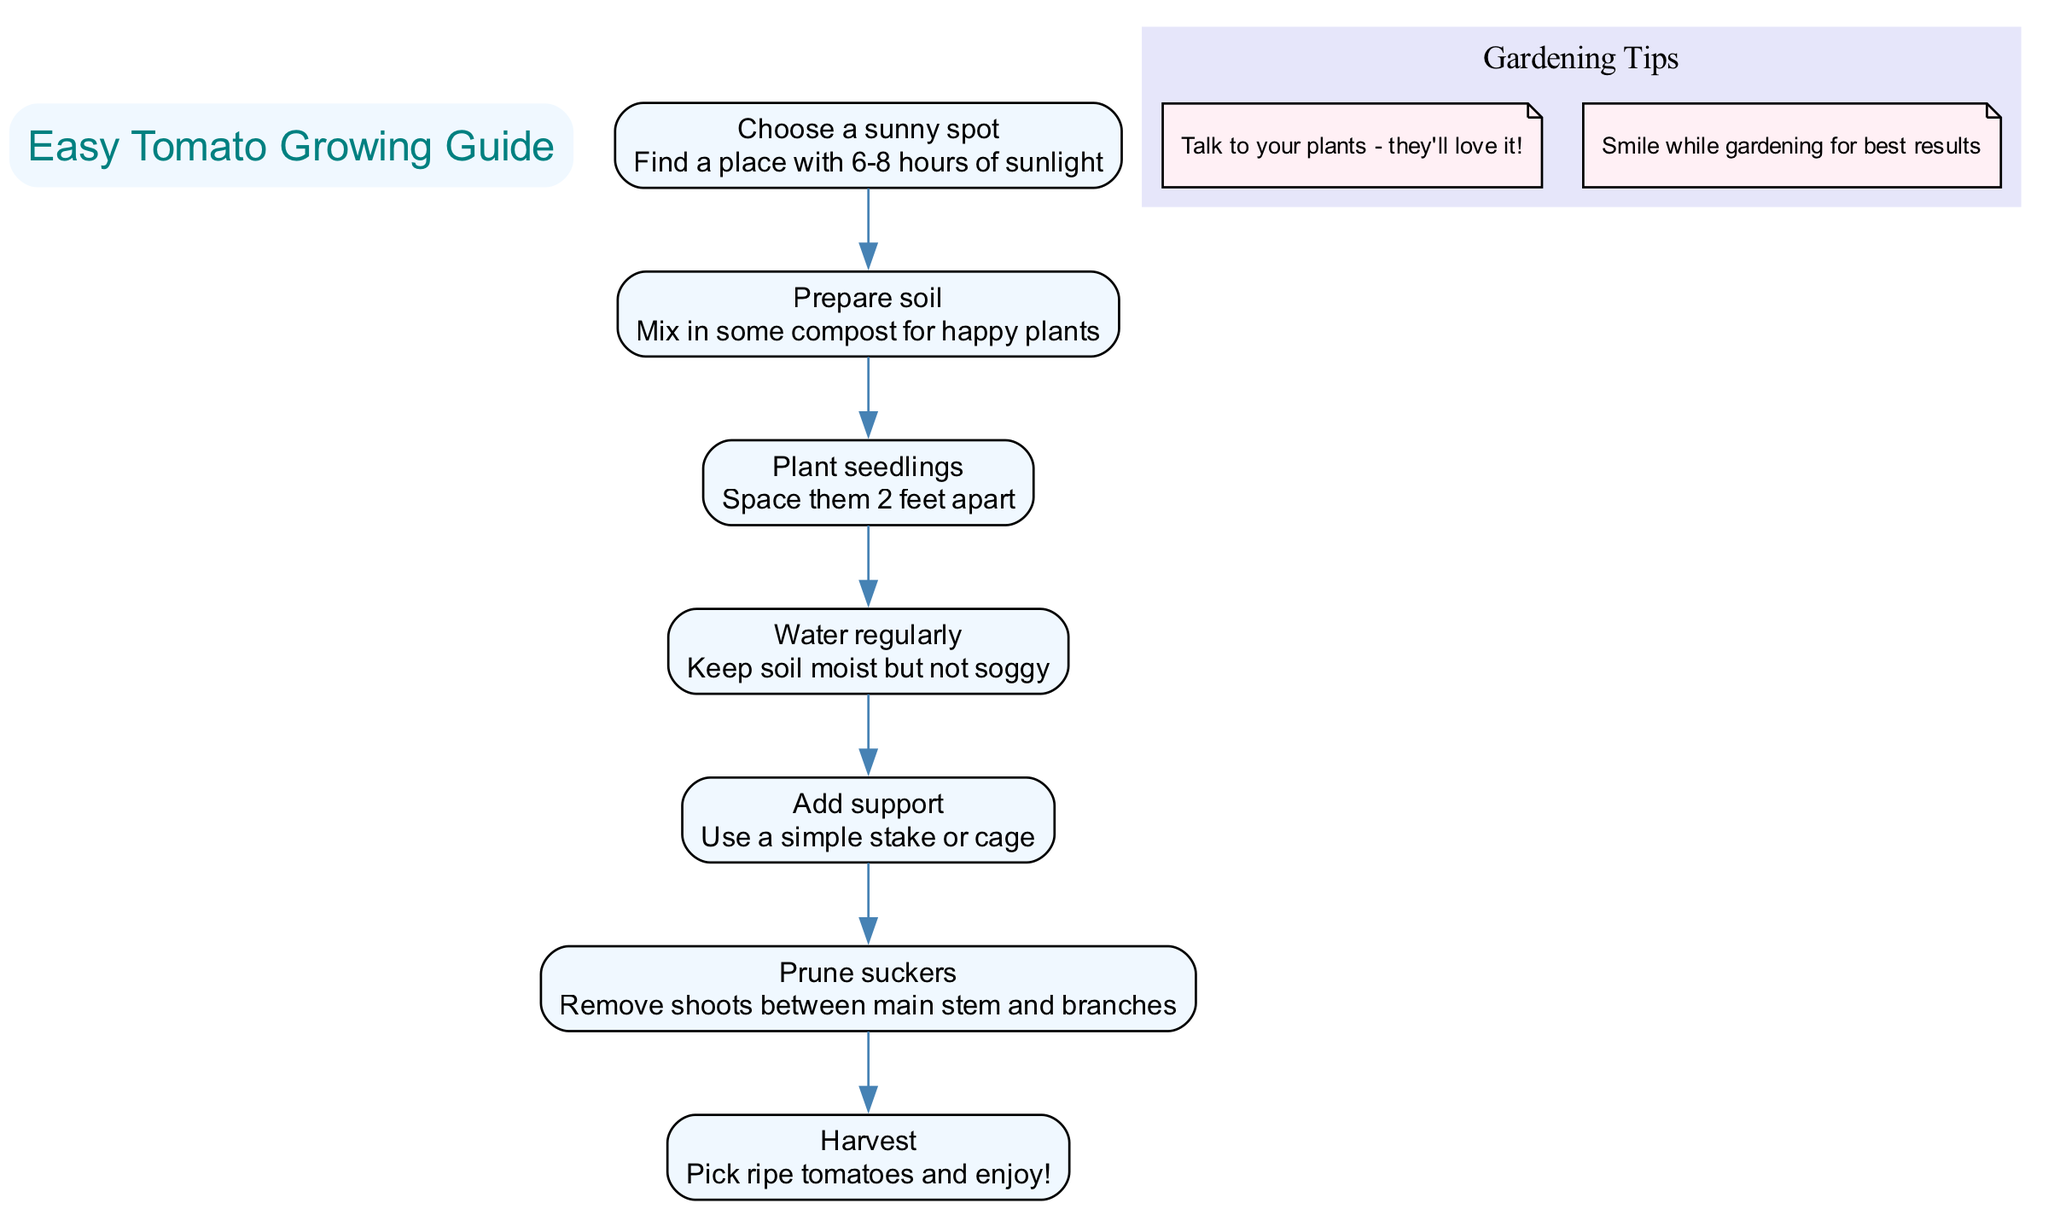What is the first step in planting a tomato? The first step listed in the diagram is to "Choose a sunny spot." This step is the first in the sequence and focuses on finding a location with sufficient sunlight.
Answer: Choose a sunny spot How many steps are in the guide? The diagram contains a total of 7 steps as outlined in the steps section. Each step is identified by a name and description which adds up to 7 sequential actions.
Answer: 7 What should you add for happy plants? The description for the second step mentions to "Mix in some compost for happy plants." This information is directly linked to the step of preparing the soil.
Answer: Compost What is the purpose of adding support? The description for the fifth step states, "Use a simple stake or cage," which indicates that the purpose of adding support is to help the tomato plant grow properly.
Answer: To help the plant grow What is the last step in the gardening guide? The final step listed in the sequence is "Harvest," which instructs to pick ripe tomatoes and enjoy them. This is the culmination of all prior steps.
Answer: Harvest What do you do with suckers? According to the sixth step, you should "Prune suckers," which means that the action involves removing the shoots that appear between the main stem and branches to promote healthy growth.
Answer: Remove shoots How many gardening tips are provided? The diagram includes 2 tips listed under a separate category for gardening tips. Each tip is positioned within its own distinct section of the diagram.
Answer: 2 What should you do to keep soil conditions? The description associated with the fourth step advises to "Keep soil moist but not soggy," guiding the care for the plant's hydration needs during growth.
Answer: Keep soil moist What effect does smiling while gardening have? One of the tips suggests that "Smile while gardening for best results," implying a positive emotional influence on the gardening process.
Answer: Positive results 